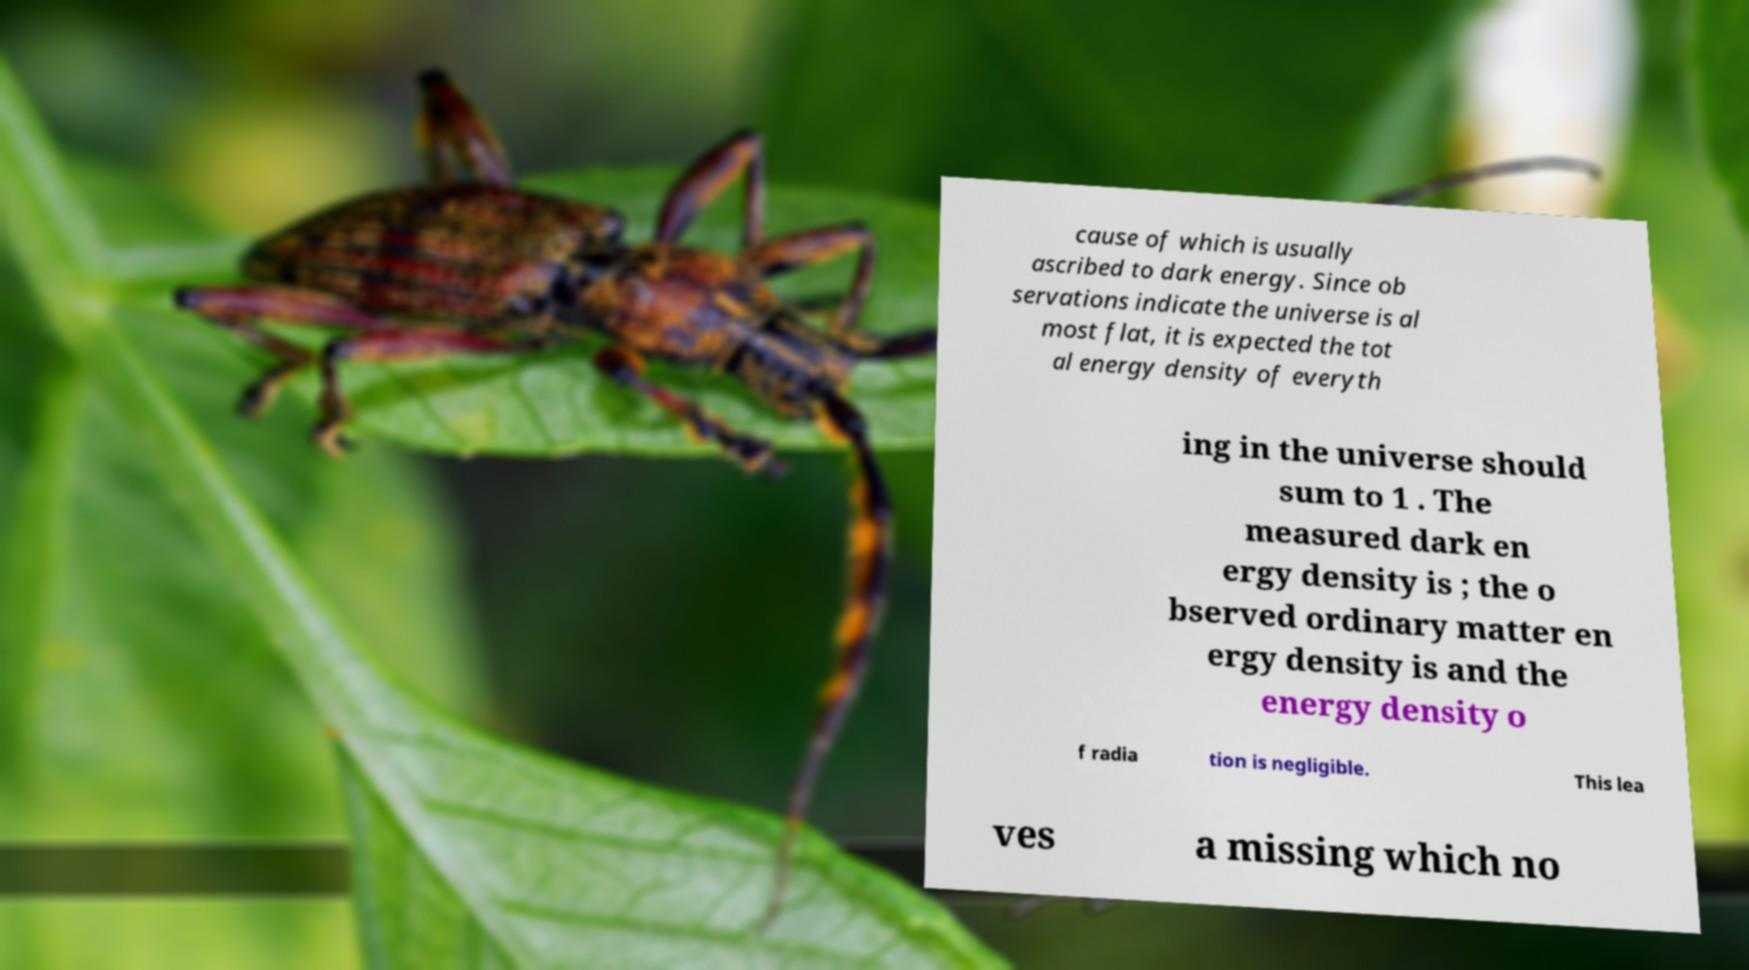Please read and relay the text visible in this image. What does it say? cause of which is usually ascribed to dark energy. Since ob servations indicate the universe is al most flat, it is expected the tot al energy density of everyth ing in the universe should sum to 1 . The measured dark en ergy density is ; the o bserved ordinary matter en ergy density is and the energy density o f radia tion is negligible. This lea ves a missing which no 